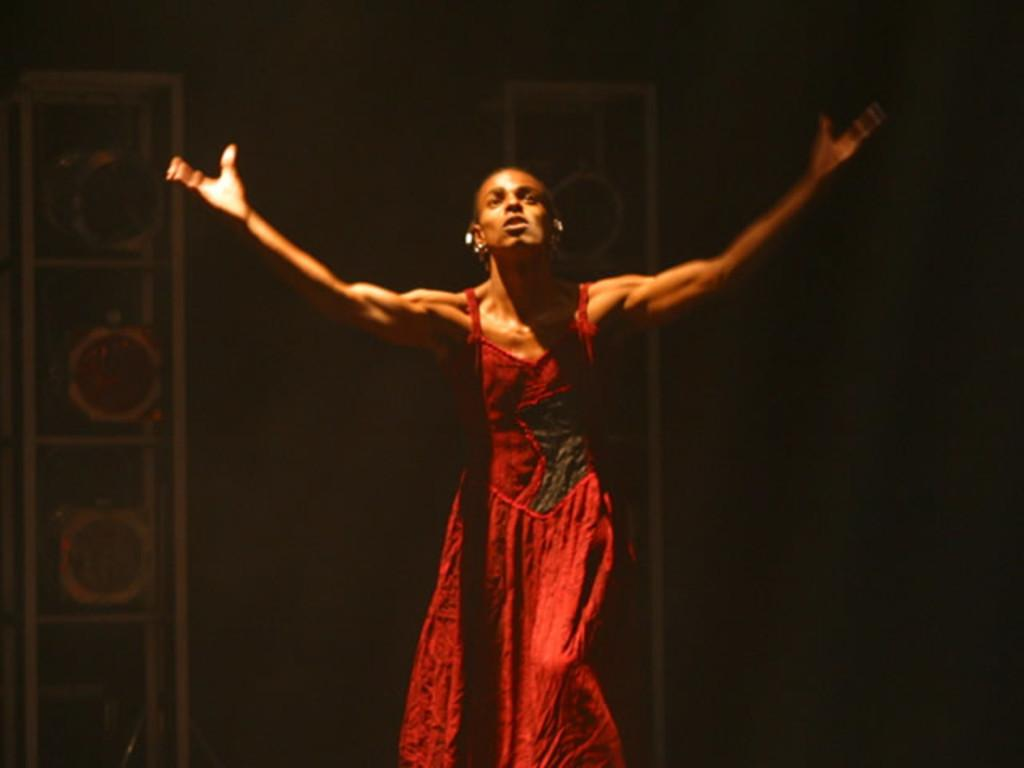What is the main subject of the image? There is a woman standing in the image. Can you describe the background of the image? The background of the image is not clear. Are there any objects visible in the background? Yes, there are objects visible in the background. What type of protest is taking place in the image? There is no protest present in the image; it features a woman standing with an unclear background. Can you tell me how deep the lake is in the image? There is no lake present in the image. 